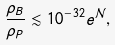Convert formula to latex. <formula><loc_0><loc_0><loc_500><loc_500>\frac { \rho _ { B } } { \rho _ { P } } \lesssim 1 0 ^ { - 3 2 } e ^ { \mathcal { N } } ,</formula> 